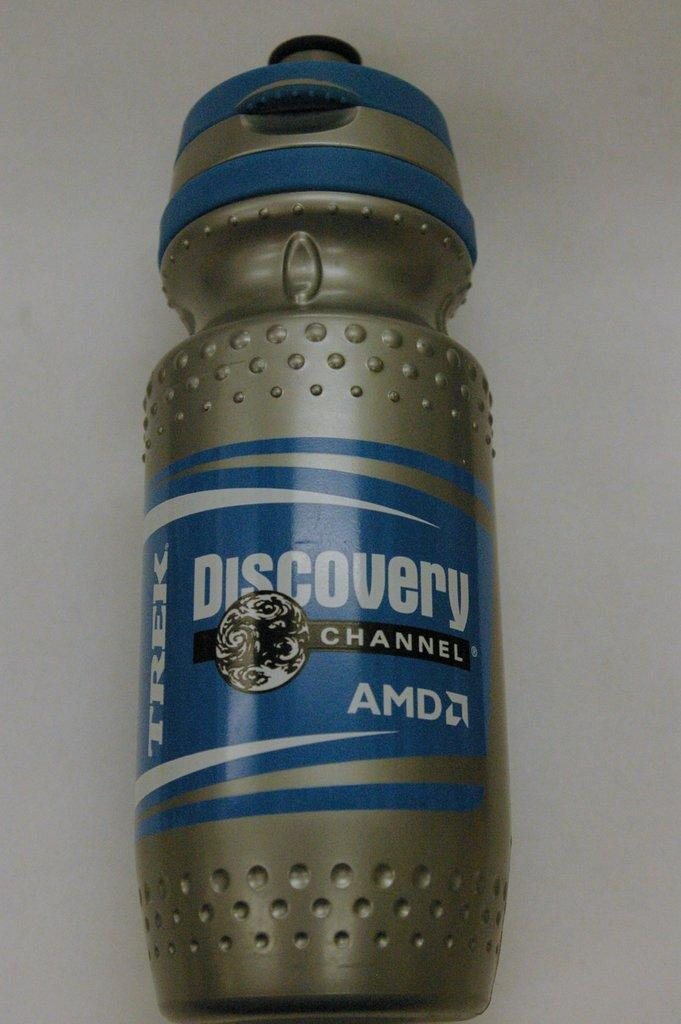What object can be seen in the image? There is a bottle in the image. What is written on the bottle? The bottle has the name "Discovery" on it. What advice does the stranger give to the grandmother in the image? There is no stranger or grandmother present in the image; it only features a bottle with the name "Discovery" on it. 